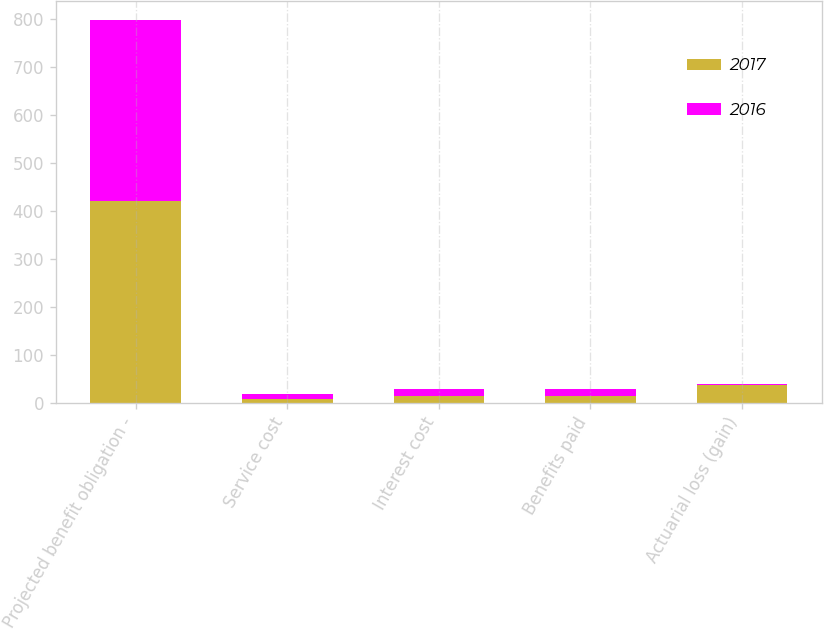Convert chart to OTSL. <chart><loc_0><loc_0><loc_500><loc_500><stacked_bar_chart><ecel><fcel>Projected benefit obligation -<fcel>Service cost<fcel>Interest cost<fcel>Benefits paid<fcel>Actuarial loss (gain)<nl><fcel>2017<fcel>420.7<fcel>8.7<fcel>14<fcel>14.9<fcel>36.9<nl><fcel>2016<fcel>376.9<fcel>9.6<fcel>13.8<fcel>14.3<fcel>1.6<nl></chart> 